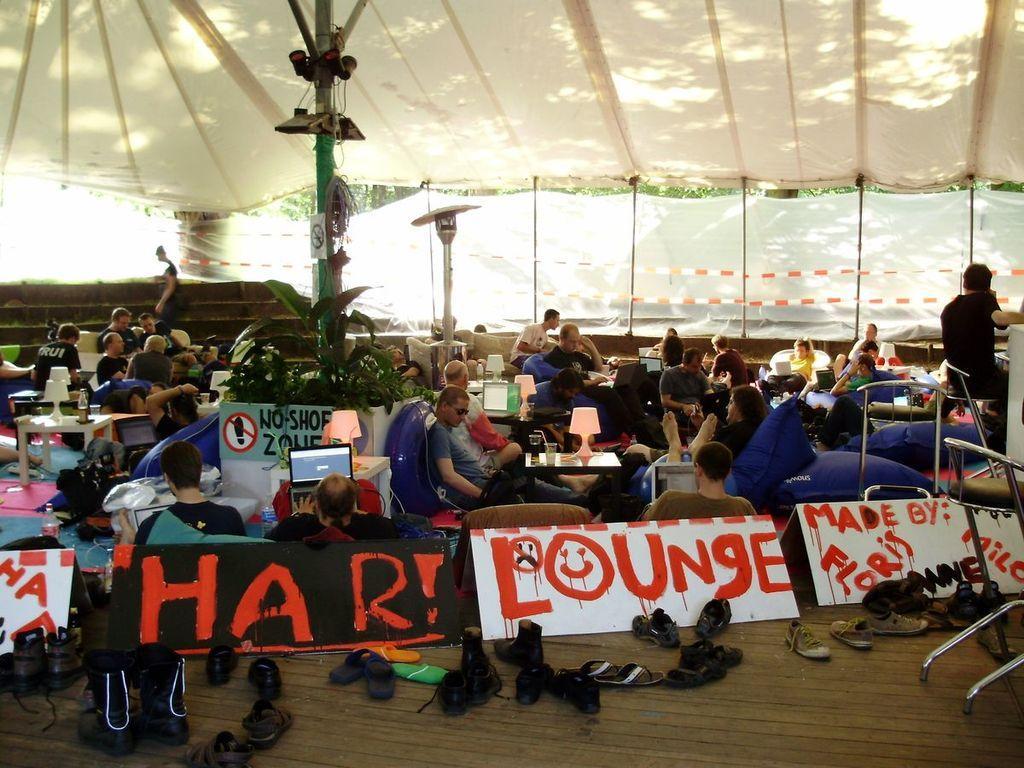Could you give a brief overview of what you see in this image? In the image we can see there are people sitting on the chair and there are table lamps kept on the table. There is a laptop kept on the table and there are hoardings kept on the floor. There is a tent on the top. 